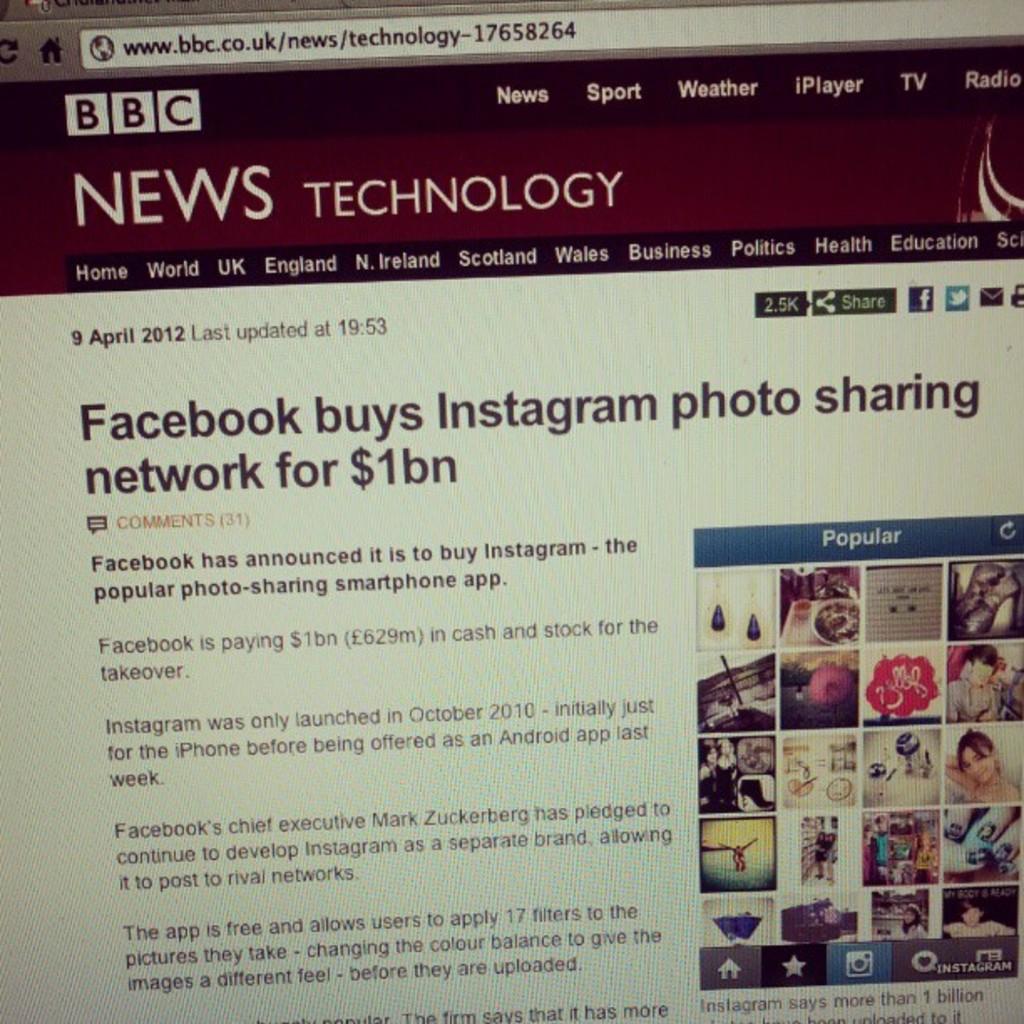What acronym is at the top of the website?
Ensure brevity in your answer.  Bbc. The page is showing bbc?
Your answer should be compact. Yes. 